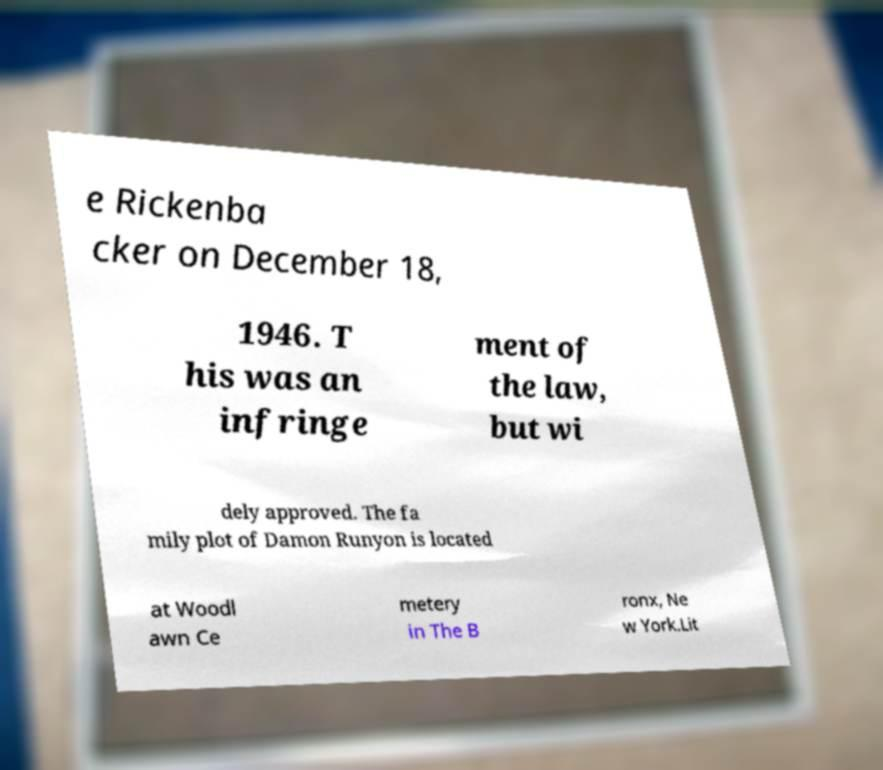There's text embedded in this image that I need extracted. Can you transcribe it verbatim? e Rickenba cker on December 18, 1946. T his was an infringe ment of the law, but wi dely approved. The fa mily plot of Damon Runyon is located at Woodl awn Ce metery in The B ronx, Ne w York.Lit 